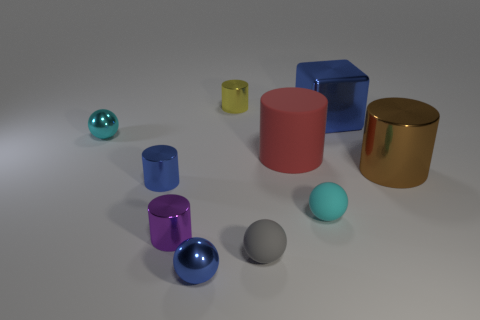What number of objects are either tiny metal things in front of the big blue object or small red cubes? 4 